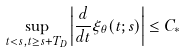<formula> <loc_0><loc_0><loc_500><loc_500>\sup _ { t < s , t \geq s + T _ { D } } \left | \frac { d } { d t } \xi _ { \theta } ( t ; s ) \right | \leq C _ { * }</formula> 